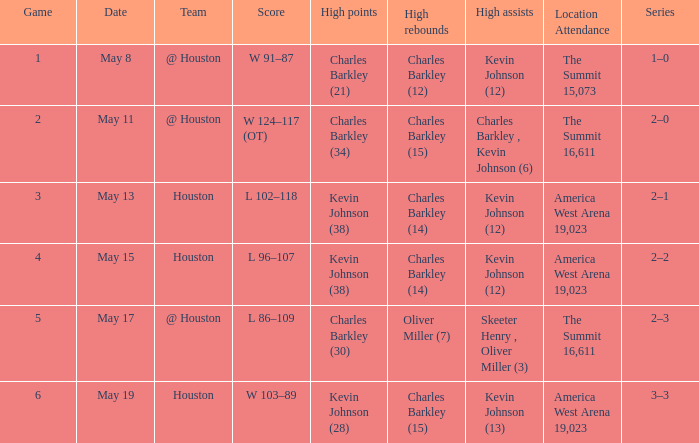In game number 1, who had the highest points? Charles Barkley (21). Would you be able to parse every entry in this table? {'header': ['Game', 'Date', 'Team', 'Score', 'High points', 'High rebounds', 'High assists', 'Location Attendance', 'Series'], 'rows': [['1', 'May 8', '@ Houston', 'W 91–87', 'Charles Barkley (21)', 'Charles Barkley (12)', 'Kevin Johnson (12)', 'The Summit 15,073', '1–0'], ['2', 'May 11', '@ Houston', 'W 124–117 (OT)', 'Charles Barkley (34)', 'Charles Barkley (15)', 'Charles Barkley , Kevin Johnson (6)', 'The Summit 16,611', '2–0'], ['3', 'May 13', 'Houston', 'L 102–118', 'Kevin Johnson (38)', 'Charles Barkley (14)', 'Kevin Johnson (12)', 'America West Arena 19,023', '2–1'], ['4', 'May 15', 'Houston', 'L 96–107', 'Kevin Johnson (38)', 'Charles Barkley (14)', 'Kevin Johnson (12)', 'America West Arena 19,023', '2–2'], ['5', 'May 17', '@ Houston', 'L 86–109', 'Charles Barkley (30)', 'Oliver Miller (7)', 'Skeeter Henry , Oliver Miller (3)', 'The Summit 16,611', '2–3'], ['6', 'May 19', 'Houston', 'W 103–89', 'Kevin Johnson (28)', 'Charles Barkley (15)', 'Kevin Johnson (13)', 'America West Arena 19,023', '3–3']]} 